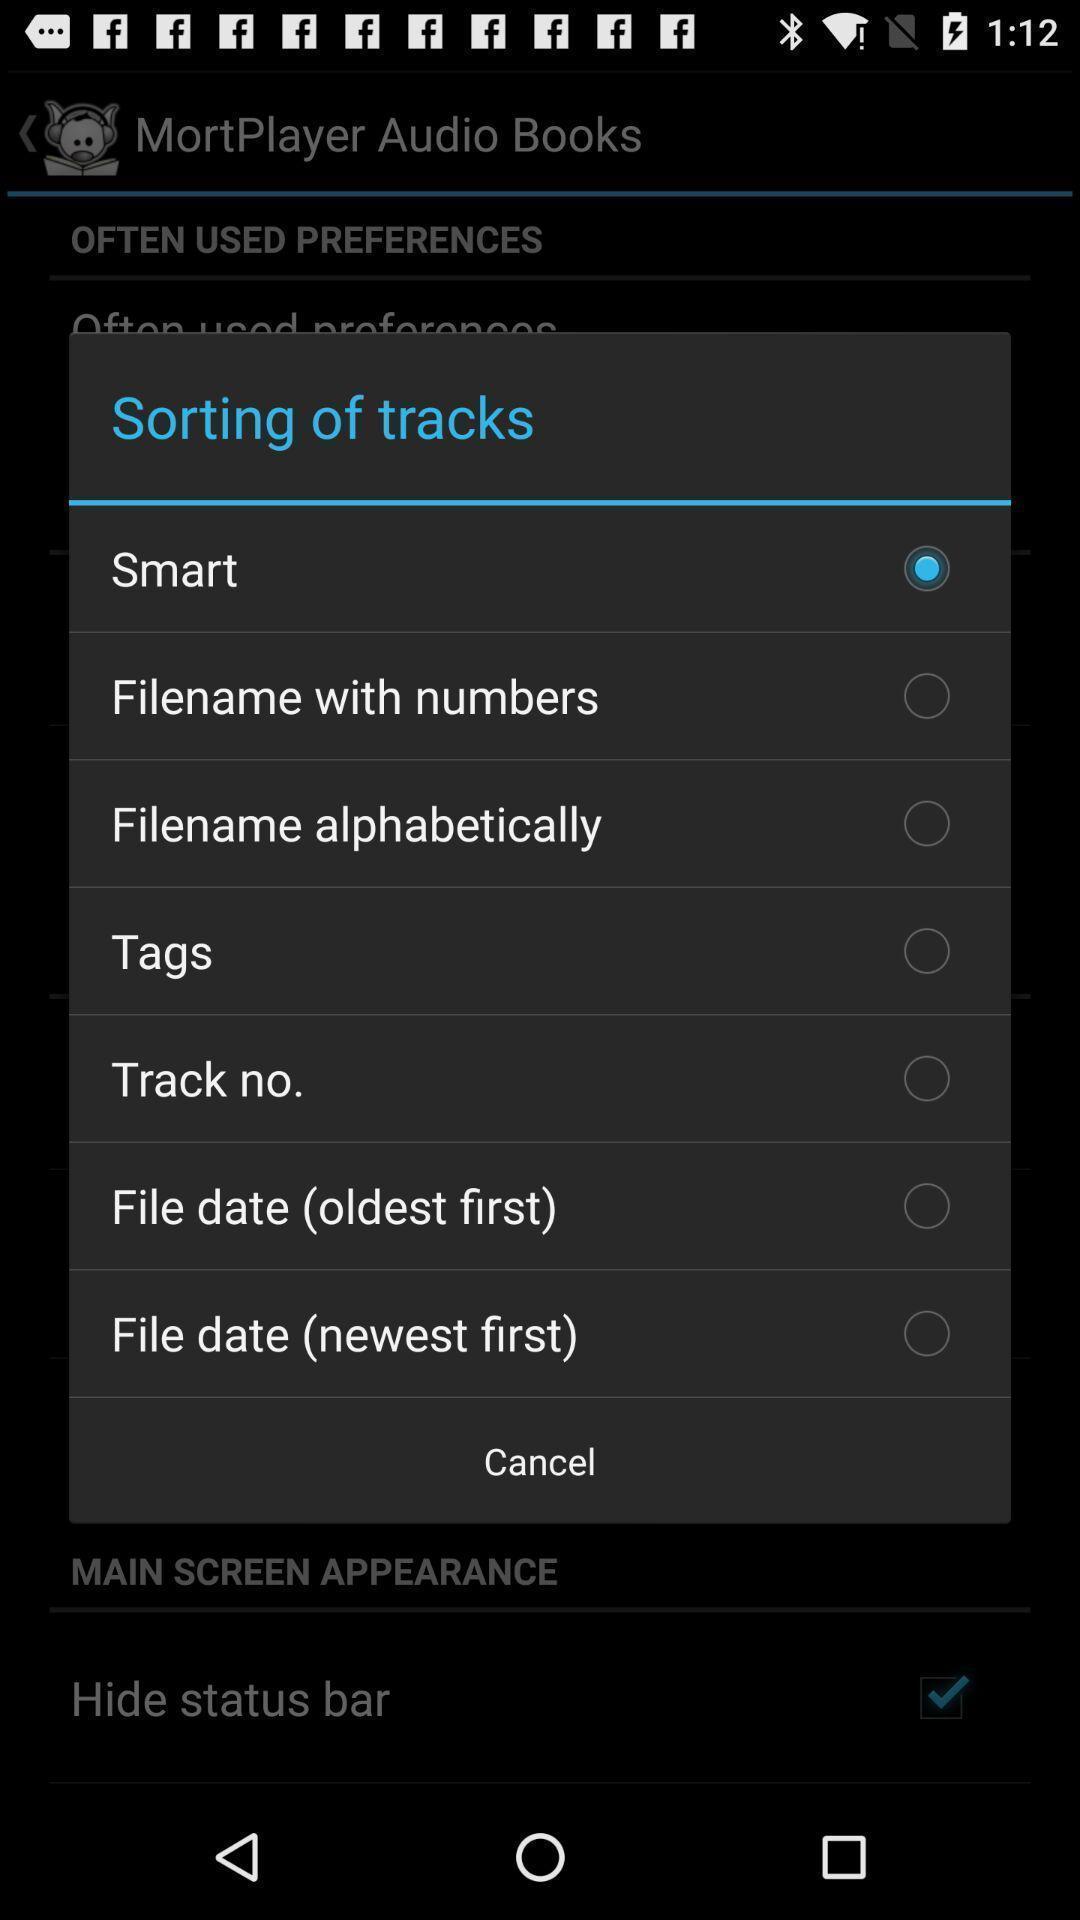Summarize the main components in this picture. Pop-up displaying to select a track in audio book. 